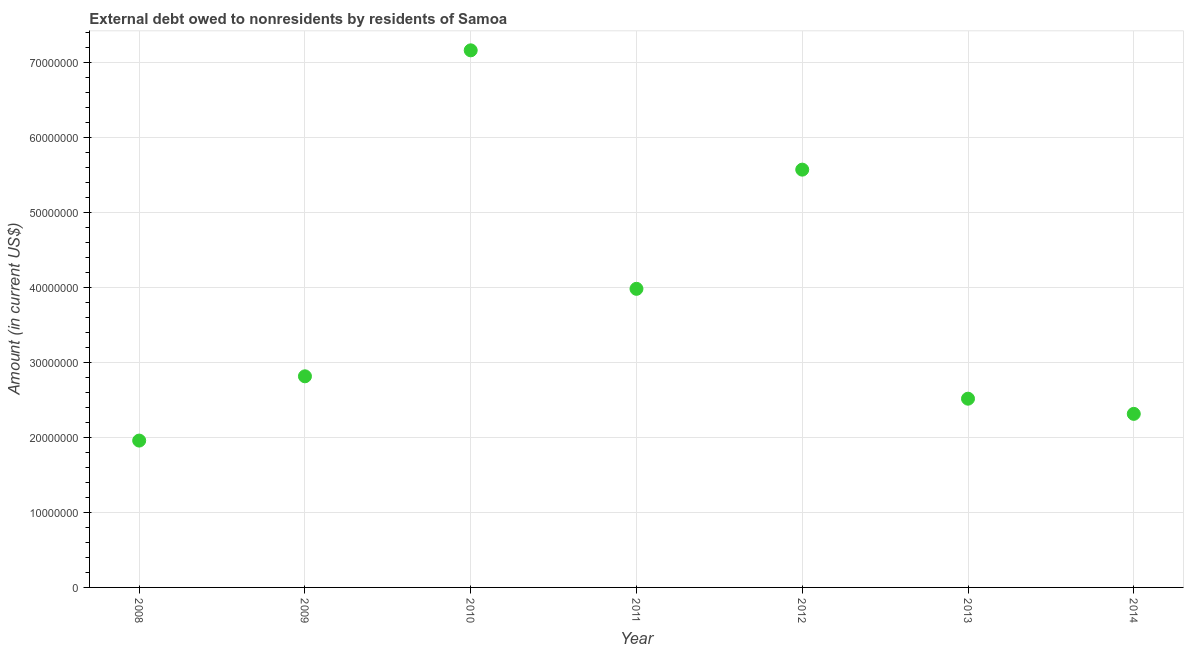What is the debt in 2013?
Your answer should be very brief. 2.52e+07. Across all years, what is the maximum debt?
Ensure brevity in your answer.  7.16e+07. Across all years, what is the minimum debt?
Your response must be concise. 1.96e+07. In which year was the debt minimum?
Make the answer very short. 2008. What is the sum of the debt?
Ensure brevity in your answer.  2.63e+08. What is the difference between the debt in 2008 and 2010?
Provide a short and direct response. -5.20e+07. What is the average debt per year?
Your answer should be very brief. 3.76e+07. What is the median debt?
Your answer should be very brief. 2.81e+07. What is the ratio of the debt in 2008 to that in 2013?
Provide a short and direct response. 0.78. What is the difference between the highest and the second highest debt?
Keep it short and to the point. 1.59e+07. What is the difference between the highest and the lowest debt?
Your answer should be compact. 5.20e+07. Are the values on the major ticks of Y-axis written in scientific E-notation?
Provide a succinct answer. No. What is the title of the graph?
Offer a terse response. External debt owed to nonresidents by residents of Samoa. What is the label or title of the Y-axis?
Your answer should be compact. Amount (in current US$). What is the Amount (in current US$) in 2008?
Your answer should be very brief. 1.96e+07. What is the Amount (in current US$) in 2009?
Your response must be concise. 2.81e+07. What is the Amount (in current US$) in 2010?
Offer a very short reply. 7.16e+07. What is the Amount (in current US$) in 2011?
Your response must be concise. 3.98e+07. What is the Amount (in current US$) in 2012?
Give a very brief answer. 5.57e+07. What is the Amount (in current US$) in 2013?
Your answer should be very brief. 2.52e+07. What is the Amount (in current US$) in 2014?
Make the answer very short. 2.31e+07. What is the difference between the Amount (in current US$) in 2008 and 2009?
Make the answer very short. -8.57e+06. What is the difference between the Amount (in current US$) in 2008 and 2010?
Offer a very short reply. -5.20e+07. What is the difference between the Amount (in current US$) in 2008 and 2011?
Ensure brevity in your answer.  -2.02e+07. What is the difference between the Amount (in current US$) in 2008 and 2012?
Give a very brief answer. -3.61e+07. What is the difference between the Amount (in current US$) in 2008 and 2013?
Give a very brief answer. -5.59e+06. What is the difference between the Amount (in current US$) in 2008 and 2014?
Give a very brief answer. -3.56e+06. What is the difference between the Amount (in current US$) in 2009 and 2010?
Your response must be concise. -4.35e+07. What is the difference between the Amount (in current US$) in 2009 and 2011?
Your answer should be compact. -1.17e+07. What is the difference between the Amount (in current US$) in 2009 and 2012?
Ensure brevity in your answer.  -2.76e+07. What is the difference between the Amount (in current US$) in 2009 and 2013?
Provide a short and direct response. 2.98e+06. What is the difference between the Amount (in current US$) in 2009 and 2014?
Your response must be concise. 5.01e+06. What is the difference between the Amount (in current US$) in 2010 and 2011?
Keep it short and to the point. 3.18e+07. What is the difference between the Amount (in current US$) in 2010 and 2012?
Give a very brief answer. 1.59e+07. What is the difference between the Amount (in current US$) in 2010 and 2013?
Ensure brevity in your answer.  4.64e+07. What is the difference between the Amount (in current US$) in 2010 and 2014?
Provide a short and direct response. 4.85e+07. What is the difference between the Amount (in current US$) in 2011 and 2012?
Your response must be concise. -1.59e+07. What is the difference between the Amount (in current US$) in 2011 and 2013?
Make the answer very short. 1.46e+07. What is the difference between the Amount (in current US$) in 2011 and 2014?
Give a very brief answer. 1.67e+07. What is the difference between the Amount (in current US$) in 2012 and 2013?
Your response must be concise. 3.05e+07. What is the difference between the Amount (in current US$) in 2012 and 2014?
Your answer should be compact. 3.26e+07. What is the difference between the Amount (in current US$) in 2013 and 2014?
Make the answer very short. 2.02e+06. What is the ratio of the Amount (in current US$) in 2008 to that in 2009?
Keep it short and to the point. 0.7. What is the ratio of the Amount (in current US$) in 2008 to that in 2010?
Your response must be concise. 0.27. What is the ratio of the Amount (in current US$) in 2008 to that in 2011?
Your response must be concise. 0.49. What is the ratio of the Amount (in current US$) in 2008 to that in 2012?
Offer a terse response. 0.35. What is the ratio of the Amount (in current US$) in 2008 to that in 2013?
Offer a very short reply. 0.78. What is the ratio of the Amount (in current US$) in 2008 to that in 2014?
Keep it short and to the point. 0.85. What is the ratio of the Amount (in current US$) in 2009 to that in 2010?
Offer a very short reply. 0.39. What is the ratio of the Amount (in current US$) in 2009 to that in 2011?
Make the answer very short. 0.71. What is the ratio of the Amount (in current US$) in 2009 to that in 2012?
Offer a terse response. 0.51. What is the ratio of the Amount (in current US$) in 2009 to that in 2013?
Your answer should be compact. 1.12. What is the ratio of the Amount (in current US$) in 2009 to that in 2014?
Give a very brief answer. 1.22. What is the ratio of the Amount (in current US$) in 2010 to that in 2011?
Offer a terse response. 1.8. What is the ratio of the Amount (in current US$) in 2010 to that in 2012?
Provide a succinct answer. 1.29. What is the ratio of the Amount (in current US$) in 2010 to that in 2013?
Provide a succinct answer. 2.85. What is the ratio of the Amount (in current US$) in 2010 to that in 2014?
Make the answer very short. 3.1. What is the ratio of the Amount (in current US$) in 2011 to that in 2012?
Give a very brief answer. 0.71. What is the ratio of the Amount (in current US$) in 2011 to that in 2013?
Provide a short and direct response. 1.58. What is the ratio of the Amount (in current US$) in 2011 to that in 2014?
Give a very brief answer. 1.72. What is the ratio of the Amount (in current US$) in 2012 to that in 2013?
Ensure brevity in your answer.  2.21. What is the ratio of the Amount (in current US$) in 2012 to that in 2014?
Offer a very short reply. 2.41. What is the ratio of the Amount (in current US$) in 2013 to that in 2014?
Offer a very short reply. 1.09. 